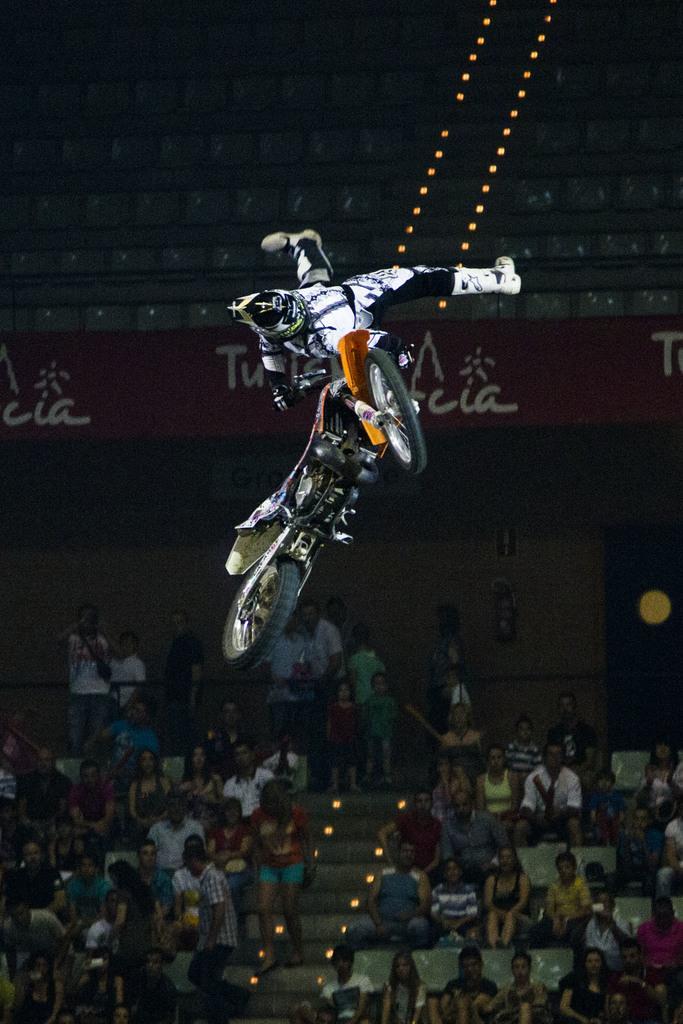How would you summarize this image in a sentence or two? In the center of the image there are people walking on the stairs. There are lights. On both right and left side of the image there are people sitting on the stairs. There is a person holding the bike and he is in the air. In the background of the image there is a banner. There are chairs. 